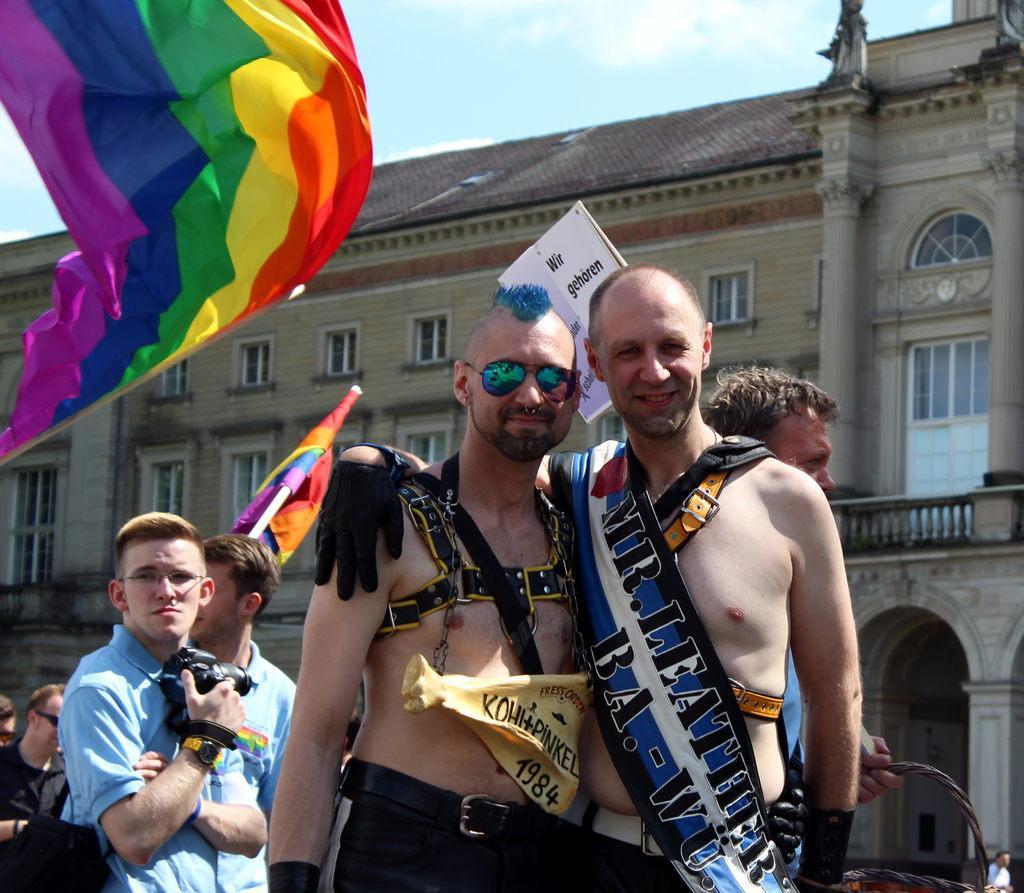Please provide a concise description of this image. In this image we can see people, flags, and a poster. In the background we can see a building, pillars, windows, and sky with clouds. 